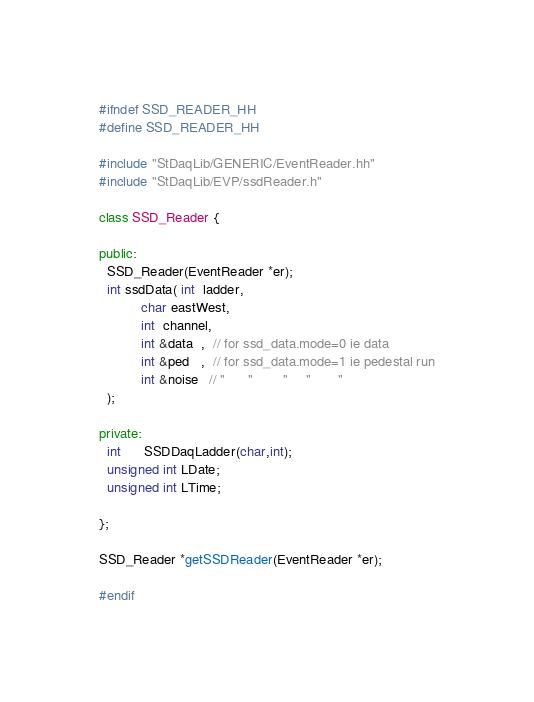Convert code to text. <code><loc_0><loc_0><loc_500><loc_500><_C++_>
#ifndef SSD_READER_HH
#define SSD_READER_HH

#include "StDaqLib/GENERIC/EventReader.hh"
#include "StDaqLib/EVP/ssdReader.h"

class SSD_Reader {

public:
  SSD_Reader(EventReader *er);
  int ssdData( int  ladder, 
	       char eastWest,
	       int  channel,
	       int &data  ,  // for ssd_data.mode=0 ie data 
	       int &ped   ,  // for ssd_data.mode=1 ie pedestal run
	       int &noise   // "      "        "     "       "
  );

private:
  int      SSDDaqLadder(char,int);
  unsigned int LDate;
  unsigned int LTime;

};

SSD_Reader *getSSDReader(EventReader *er);

#endif
</code> 